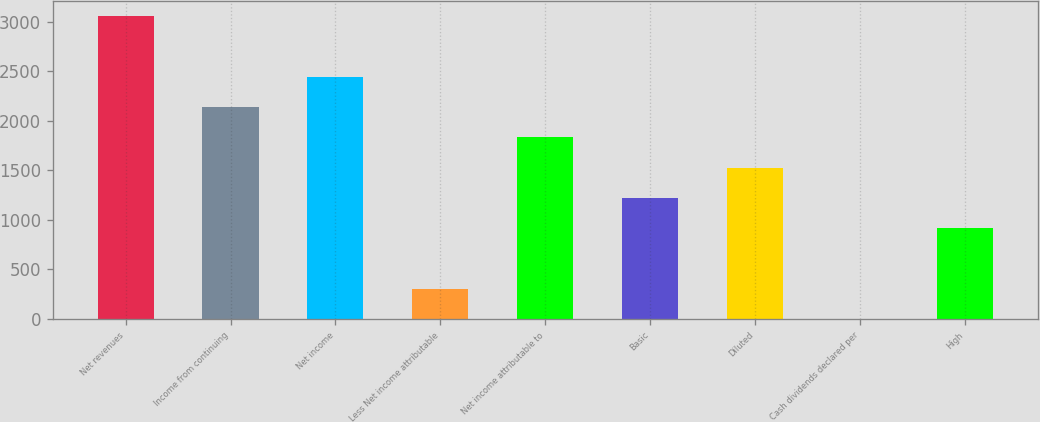Convert chart. <chart><loc_0><loc_0><loc_500><loc_500><bar_chart><fcel>Net revenues<fcel>Income from continuing<fcel>Net income<fcel>Less Net income attributable<fcel>Net income attributable to<fcel>Basic<fcel>Diluted<fcel>Cash dividends declared per<fcel>High<nl><fcel>3053<fcel>2137.26<fcel>2442.5<fcel>305.82<fcel>1832.02<fcel>1221.54<fcel>1526.78<fcel>0.58<fcel>916.3<nl></chart> 